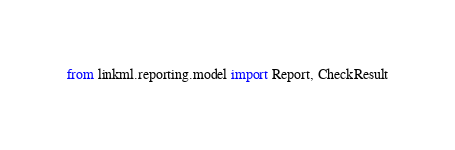<code> <loc_0><loc_0><loc_500><loc_500><_Python_>from linkml.reporting.model import Report, CheckResult</code> 